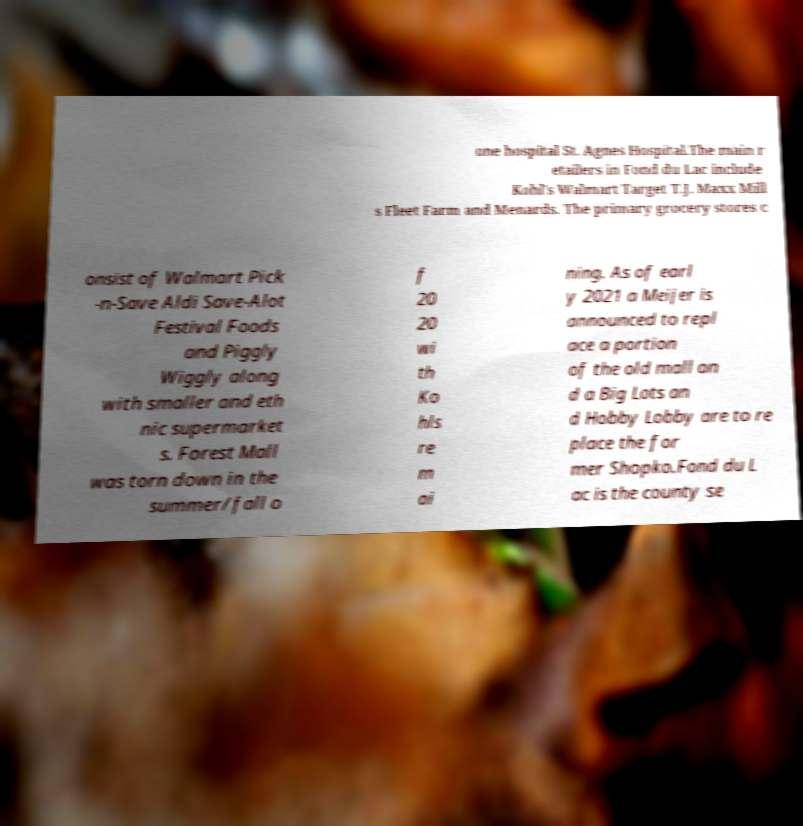Please identify and transcribe the text found in this image. one hospital St. Agnes Hospital.The main r etailers in Fond du Lac include Kohl's Walmart Target T.J. Maxx Mill s Fleet Farm and Menards. The primary grocery stores c onsist of Walmart Pick -n-Save Aldi Save-Alot Festival Foods and Piggly Wiggly along with smaller and eth nic supermarket s. Forest Mall was torn down in the summer/fall o f 20 20 wi th Ko hls re m ai ning. As of earl y 2021 a Meijer is announced to repl ace a portion of the old mall an d a Big Lots an d Hobby Lobby are to re place the for mer Shopko.Fond du L ac is the county se 